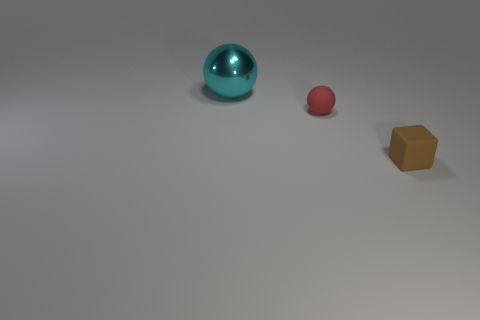Is there anything else that is the same size as the cyan metallic object?
Ensure brevity in your answer.  No. What number of objects are either tiny brown matte objects or tiny brown metal cylinders?
Provide a succinct answer. 1. Is there a red thing that has the same size as the brown matte block?
Make the answer very short. Yes. What is the shape of the brown rubber thing?
Make the answer very short. Cube. Are there more things right of the small red object than big cyan spheres that are in front of the big cyan ball?
Provide a short and direct response. Yes. What shape is the brown object that is the same size as the red thing?
Give a very brief answer. Cube. Is there another brown thing that has the same shape as the large object?
Provide a short and direct response. No. Is the material of the thing in front of the small matte sphere the same as the sphere that is left of the small sphere?
Provide a succinct answer. No. How many cubes have the same material as the big thing?
Give a very brief answer. 0. What is the color of the tiny block?
Give a very brief answer. Brown. 